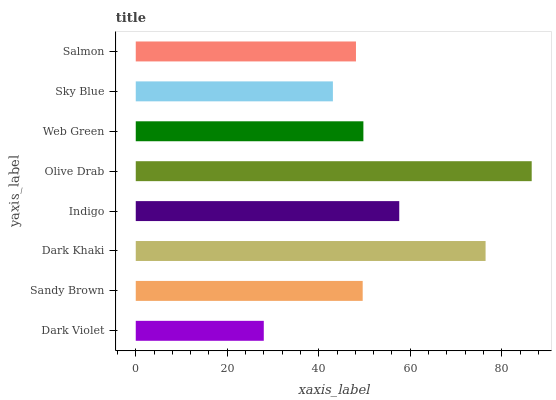Is Dark Violet the minimum?
Answer yes or no. Yes. Is Olive Drab the maximum?
Answer yes or no. Yes. Is Sandy Brown the minimum?
Answer yes or no. No. Is Sandy Brown the maximum?
Answer yes or no. No. Is Sandy Brown greater than Dark Violet?
Answer yes or no. Yes. Is Dark Violet less than Sandy Brown?
Answer yes or no. Yes. Is Dark Violet greater than Sandy Brown?
Answer yes or no. No. Is Sandy Brown less than Dark Violet?
Answer yes or no. No. Is Web Green the high median?
Answer yes or no. Yes. Is Sandy Brown the low median?
Answer yes or no. Yes. Is Dark Violet the high median?
Answer yes or no. No. Is Web Green the low median?
Answer yes or no. No. 